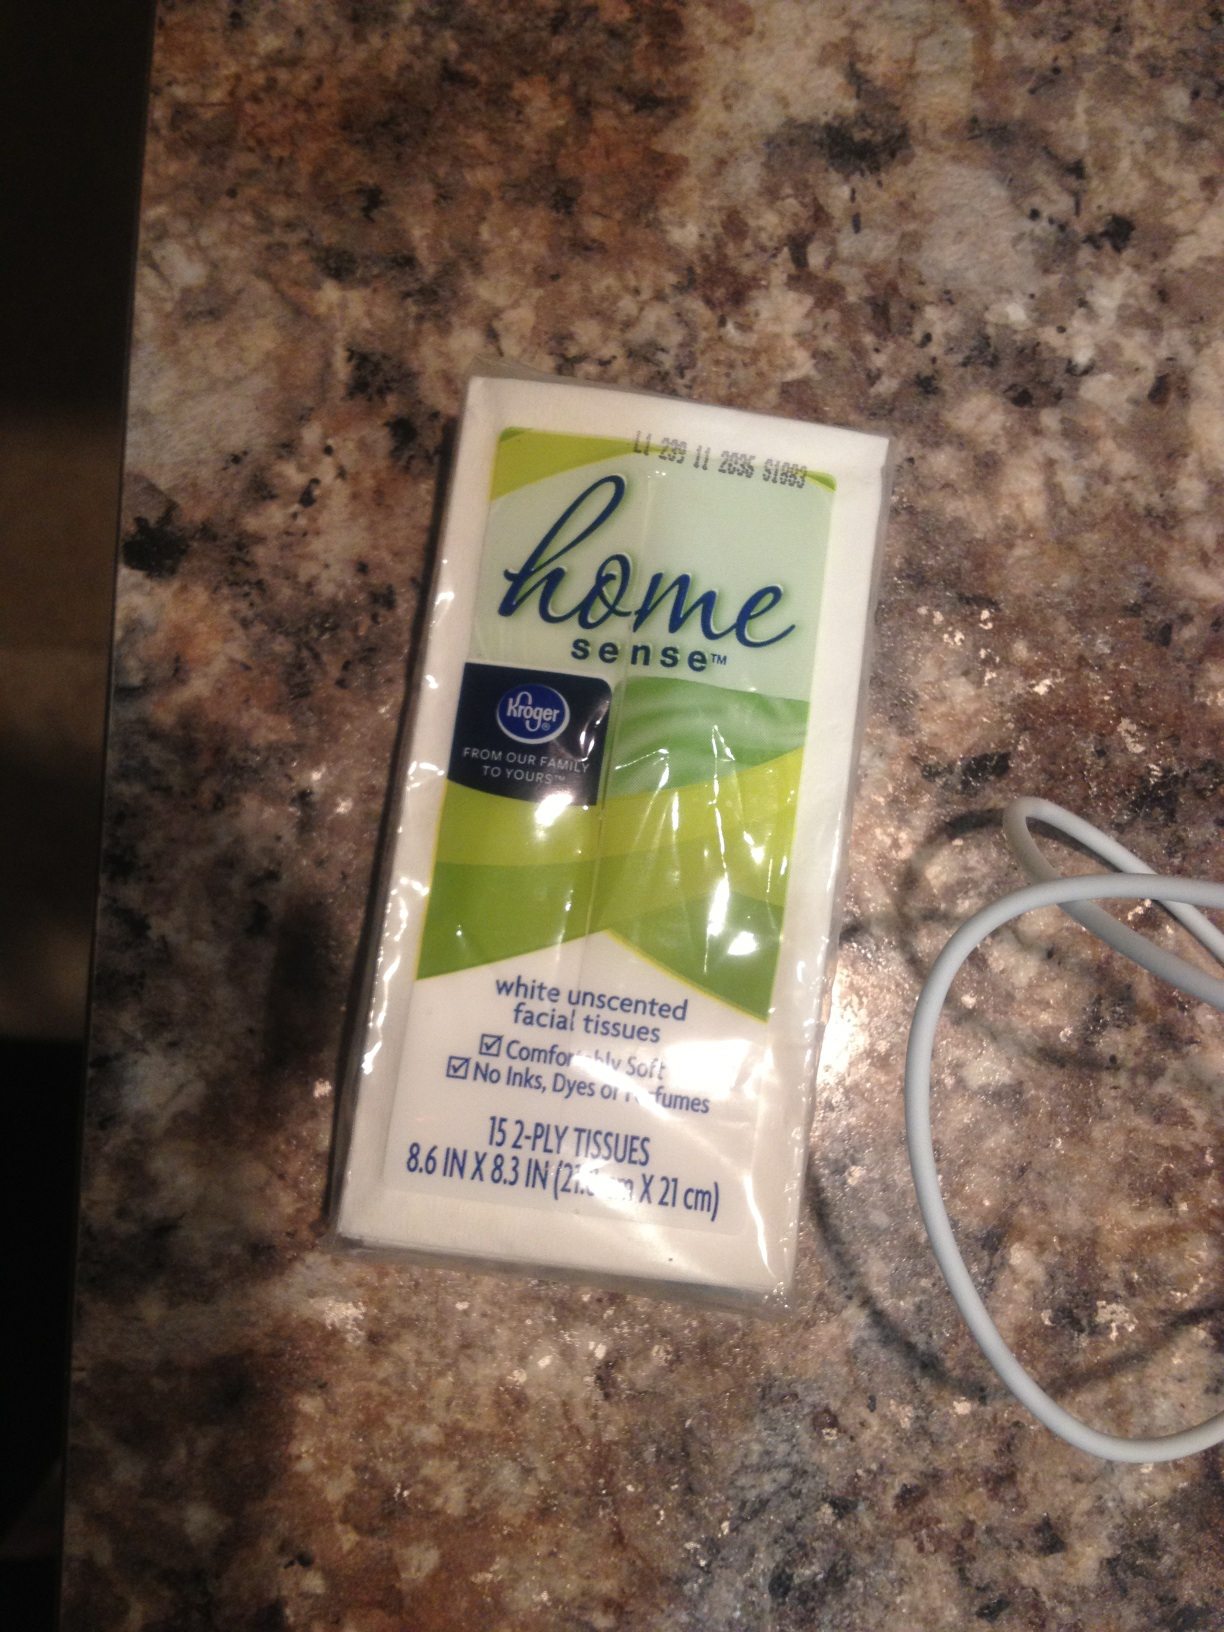If these tissues could talk, what story would they tell from their factory to the consumer? If these tissues could talk, they would share their journey from being carefully woven in a factory where sheets of soft, absorbent paper are created. They would recount their packaging process, where each tissue is meticulously folded and packed with others to form a compact, easy-to-carry ensemble. Finally, they would express their satisfaction in being of service to consumers, ready to tackle any spill or wipe a tear. 